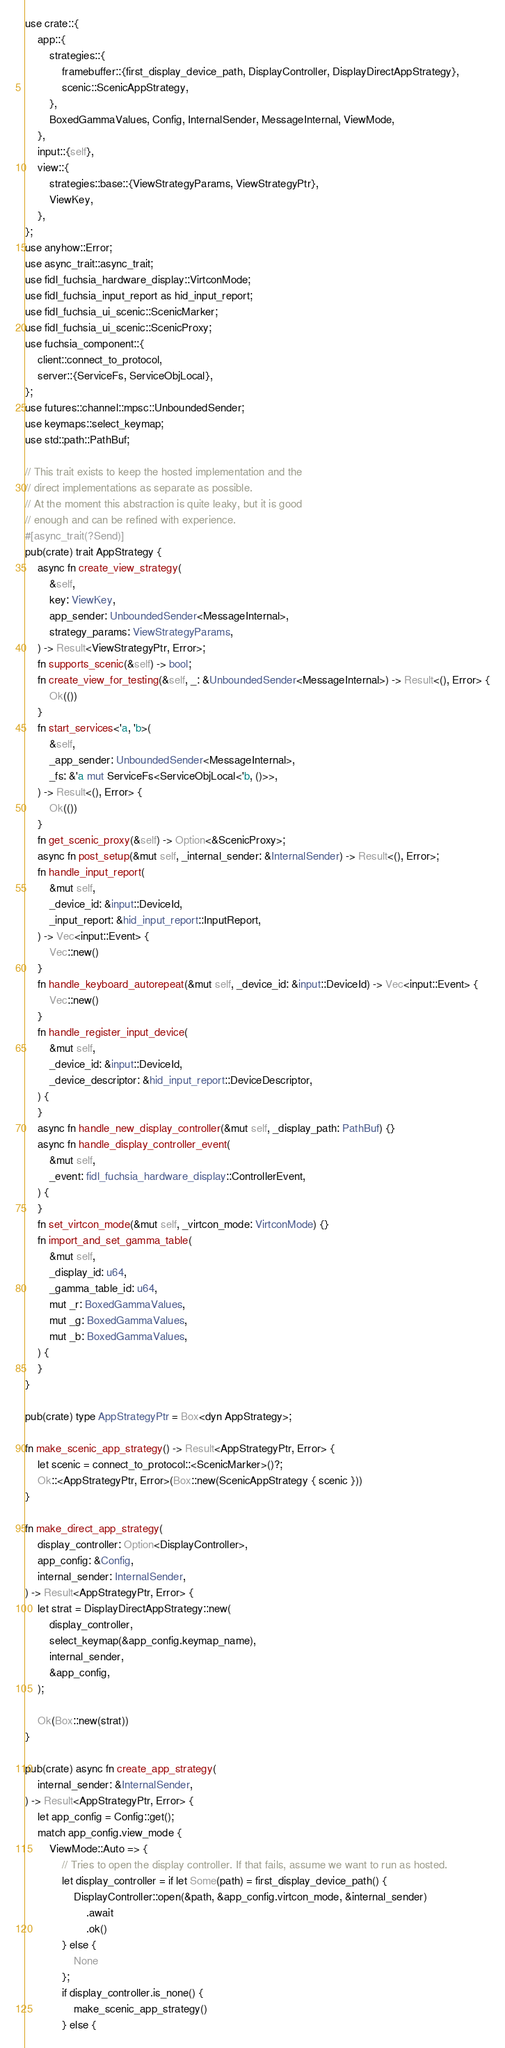Convert code to text. <code><loc_0><loc_0><loc_500><loc_500><_Rust_>
use crate::{
    app::{
        strategies::{
            framebuffer::{first_display_device_path, DisplayController, DisplayDirectAppStrategy},
            scenic::ScenicAppStrategy,
        },
        BoxedGammaValues, Config, InternalSender, MessageInternal, ViewMode,
    },
    input::{self},
    view::{
        strategies::base::{ViewStrategyParams, ViewStrategyPtr},
        ViewKey,
    },
};
use anyhow::Error;
use async_trait::async_trait;
use fidl_fuchsia_hardware_display::VirtconMode;
use fidl_fuchsia_input_report as hid_input_report;
use fidl_fuchsia_ui_scenic::ScenicMarker;
use fidl_fuchsia_ui_scenic::ScenicProxy;
use fuchsia_component::{
    client::connect_to_protocol,
    server::{ServiceFs, ServiceObjLocal},
};
use futures::channel::mpsc::UnboundedSender;
use keymaps::select_keymap;
use std::path::PathBuf;

// This trait exists to keep the hosted implementation and the
// direct implementations as separate as possible.
// At the moment this abstraction is quite leaky, but it is good
// enough and can be refined with experience.
#[async_trait(?Send)]
pub(crate) trait AppStrategy {
    async fn create_view_strategy(
        &self,
        key: ViewKey,
        app_sender: UnboundedSender<MessageInternal>,
        strategy_params: ViewStrategyParams,
    ) -> Result<ViewStrategyPtr, Error>;
    fn supports_scenic(&self) -> bool;
    fn create_view_for_testing(&self, _: &UnboundedSender<MessageInternal>) -> Result<(), Error> {
        Ok(())
    }
    fn start_services<'a, 'b>(
        &self,
        _app_sender: UnboundedSender<MessageInternal>,
        _fs: &'a mut ServiceFs<ServiceObjLocal<'b, ()>>,
    ) -> Result<(), Error> {
        Ok(())
    }
    fn get_scenic_proxy(&self) -> Option<&ScenicProxy>;
    async fn post_setup(&mut self, _internal_sender: &InternalSender) -> Result<(), Error>;
    fn handle_input_report(
        &mut self,
        _device_id: &input::DeviceId,
        _input_report: &hid_input_report::InputReport,
    ) -> Vec<input::Event> {
        Vec::new()
    }
    fn handle_keyboard_autorepeat(&mut self, _device_id: &input::DeviceId) -> Vec<input::Event> {
        Vec::new()
    }
    fn handle_register_input_device(
        &mut self,
        _device_id: &input::DeviceId,
        _device_descriptor: &hid_input_report::DeviceDescriptor,
    ) {
    }
    async fn handle_new_display_controller(&mut self, _display_path: PathBuf) {}
    async fn handle_display_controller_event(
        &mut self,
        _event: fidl_fuchsia_hardware_display::ControllerEvent,
    ) {
    }
    fn set_virtcon_mode(&mut self, _virtcon_mode: VirtconMode) {}
    fn import_and_set_gamma_table(
        &mut self,
        _display_id: u64,
        _gamma_table_id: u64,
        mut _r: BoxedGammaValues,
        mut _g: BoxedGammaValues,
        mut _b: BoxedGammaValues,
    ) {
    }
}

pub(crate) type AppStrategyPtr = Box<dyn AppStrategy>;

fn make_scenic_app_strategy() -> Result<AppStrategyPtr, Error> {
    let scenic = connect_to_protocol::<ScenicMarker>()?;
    Ok::<AppStrategyPtr, Error>(Box::new(ScenicAppStrategy { scenic }))
}

fn make_direct_app_strategy(
    display_controller: Option<DisplayController>,
    app_config: &Config,
    internal_sender: InternalSender,
) -> Result<AppStrategyPtr, Error> {
    let strat = DisplayDirectAppStrategy::new(
        display_controller,
        select_keymap(&app_config.keymap_name),
        internal_sender,
        &app_config,
    );

    Ok(Box::new(strat))
}

pub(crate) async fn create_app_strategy(
    internal_sender: &InternalSender,
) -> Result<AppStrategyPtr, Error> {
    let app_config = Config::get();
    match app_config.view_mode {
        ViewMode::Auto => {
            // Tries to open the display controller. If that fails, assume we want to run as hosted.
            let display_controller = if let Some(path) = first_display_device_path() {
                DisplayController::open(&path, &app_config.virtcon_mode, &internal_sender)
                    .await
                    .ok()
            } else {
                None
            };
            if display_controller.is_none() {
                make_scenic_app_strategy()
            } else {</code> 